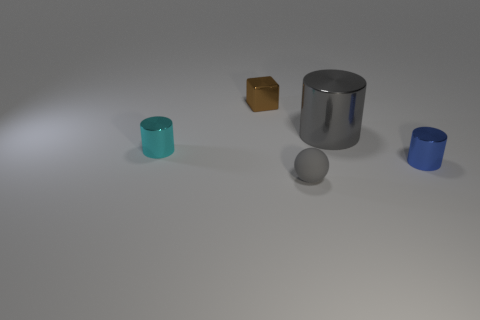Add 5 tiny gray rubber cylinders. How many objects exist? 10 Subtract all balls. How many objects are left? 4 Add 1 small brown cubes. How many small brown cubes are left? 2 Add 4 small green rubber things. How many small green rubber things exist? 4 Subtract 0 red cubes. How many objects are left? 5 Subtract all big cyan cubes. Subtract all gray matte objects. How many objects are left? 4 